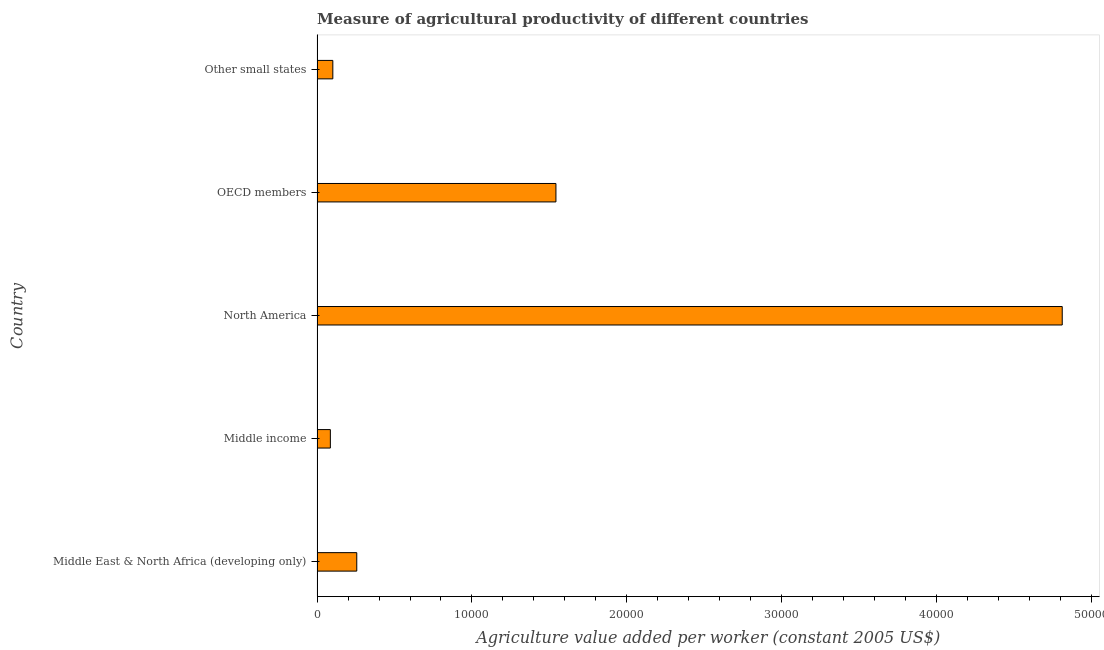Does the graph contain grids?
Provide a short and direct response. No. What is the title of the graph?
Your answer should be compact. Measure of agricultural productivity of different countries. What is the label or title of the X-axis?
Your answer should be compact. Agriculture value added per worker (constant 2005 US$). What is the agriculture value added per worker in Other small states?
Give a very brief answer. 1018.37. Across all countries, what is the maximum agriculture value added per worker?
Keep it short and to the point. 4.81e+04. Across all countries, what is the minimum agriculture value added per worker?
Provide a succinct answer. 858.89. In which country was the agriculture value added per worker maximum?
Your response must be concise. North America. In which country was the agriculture value added per worker minimum?
Make the answer very short. Middle income. What is the sum of the agriculture value added per worker?
Make the answer very short. 6.80e+04. What is the difference between the agriculture value added per worker in OECD members and Other small states?
Make the answer very short. 1.44e+04. What is the average agriculture value added per worker per country?
Ensure brevity in your answer.  1.36e+04. What is the median agriculture value added per worker?
Your response must be concise. 2563.27. What is the ratio of the agriculture value added per worker in Middle income to that in Other small states?
Your answer should be compact. 0.84. Is the agriculture value added per worker in Middle income less than that in Other small states?
Provide a succinct answer. Yes. Is the difference between the agriculture value added per worker in Middle East & North Africa (developing only) and OECD members greater than the difference between any two countries?
Offer a terse response. No. What is the difference between the highest and the second highest agriculture value added per worker?
Provide a succinct answer. 3.27e+04. What is the difference between the highest and the lowest agriculture value added per worker?
Your response must be concise. 4.72e+04. In how many countries, is the agriculture value added per worker greater than the average agriculture value added per worker taken over all countries?
Give a very brief answer. 2. How many bars are there?
Give a very brief answer. 5. Are all the bars in the graph horizontal?
Ensure brevity in your answer.  Yes. Are the values on the major ticks of X-axis written in scientific E-notation?
Offer a terse response. No. What is the Agriculture value added per worker (constant 2005 US$) of Middle East & North Africa (developing only)?
Ensure brevity in your answer.  2563.27. What is the Agriculture value added per worker (constant 2005 US$) in Middle income?
Ensure brevity in your answer.  858.89. What is the Agriculture value added per worker (constant 2005 US$) in North America?
Ensure brevity in your answer.  4.81e+04. What is the Agriculture value added per worker (constant 2005 US$) in OECD members?
Give a very brief answer. 1.54e+04. What is the Agriculture value added per worker (constant 2005 US$) in Other small states?
Give a very brief answer. 1018.37. What is the difference between the Agriculture value added per worker (constant 2005 US$) in Middle East & North Africa (developing only) and Middle income?
Your answer should be very brief. 1704.38. What is the difference between the Agriculture value added per worker (constant 2005 US$) in Middle East & North Africa (developing only) and North America?
Offer a very short reply. -4.55e+04. What is the difference between the Agriculture value added per worker (constant 2005 US$) in Middle East & North Africa (developing only) and OECD members?
Give a very brief answer. -1.29e+04. What is the difference between the Agriculture value added per worker (constant 2005 US$) in Middle East & North Africa (developing only) and Other small states?
Keep it short and to the point. 1544.9. What is the difference between the Agriculture value added per worker (constant 2005 US$) in Middle income and North America?
Offer a terse response. -4.72e+04. What is the difference between the Agriculture value added per worker (constant 2005 US$) in Middle income and OECD members?
Offer a terse response. -1.46e+04. What is the difference between the Agriculture value added per worker (constant 2005 US$) in Middle income and Other small states?
Offer a very short reply. -159.48. What is the difference between the Agriculture value added per worker (constant 2005 US$) in North America and OECD members?
Ensure brevity in your answer.  3.27e+04. What is the difference between the Agriculture value added per worker (constant 2005 US$) in North America and Other small states?
Offer a terse response. 4.71e+04. What is the difference between the Agriculture value added per worker (constant 2005 US$) in OECD members and Other small states?
Provide a succinct answer. 1.44e+04. What is the ratio of the Agriculture value added per worker (constant 2005 US$) in Middle East & North Africa (developing only) to that in Middle income?
Provide a succinct answer. 2.98. What is the ratio of the Agriculture value added per worker (constant 2005 US$) in Middle East & North Africa (developing only) to that in North America?
Provide a short and direct response. 0.05. What is the ratio of the Agriculture value added per worker (constant 2005 US$) in Middle East & North Africa (developing only) to that in OECD members?
Provide a succinct answer. 0.17. What is the ratio of the Agriculture value added per worker (constant 2005 US$) in Middle East & North Africa (developing only) to that in Other small states?
Give a very brief answer. 2.52. What is the ratio of the Agriculture value added per worker (constant 2005 US$) in Middle income to that in North America?
Your answer should be compact. 0.02. What is the ratio of the Agriculture value added per worker (constant 2005 US$) in Middle income to that in OECD members?
Offer a terse response. 0.06. What is the ratio of the Agriculture value added per worker (constant 2005 US$) in Middle income to that in Other small states?
Your response must be concise. 0.84. What is the ratio of the Agriculture value added per worker (constant 2005 US$) in North America to that in OECD members?
Make the answer very short. 3.12. What is the ratio of the Agriculture value added per worker (constant 2005 US$) in North America to that in Other small states?
Ensure brevity in your answer.  47.23. What is the ratio of the Agriculture value added per worker (constant 2005 US$) in OECD members to that in Other small states?
Provide a succinct answer. 15.14. 